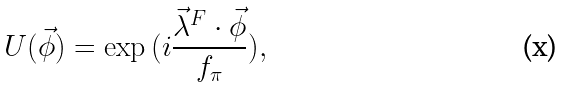<formula> <loc_0><loc_0><loc_500><loc_500>U ( \vec { \phi } ) = \exp { ( i \frac { \vec { \lambda } ^ { F } \cdot \vec { \phi } } { f _ { \pi } } ) } ,</formula> 